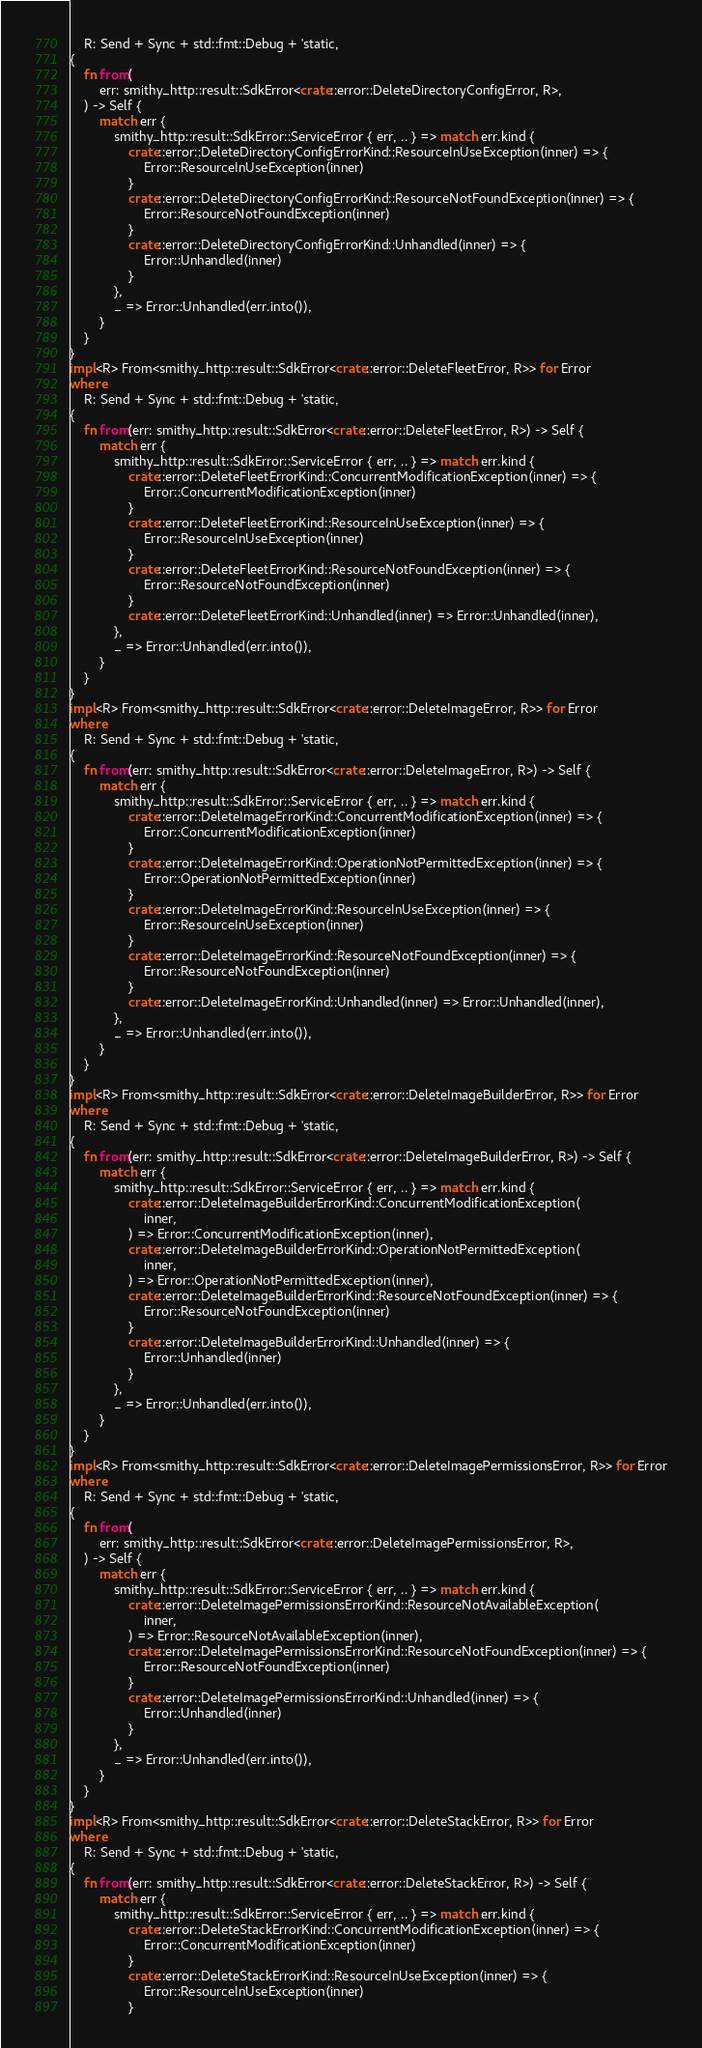Convert code to text. <code><loc_0><loc_0><loc_500><loc_500><_Rust_>    R: Send + Sync + std::fmt::Debug + 'static,
{
    fn from(
        err: smithy_http::result::SdkError<crate::error::DeleteDirectoryConfigError, R>,
    ) -> Self {
        match err {
            smithy_http::result::SdkError::ServiceError { err, .. } => match err.kind {
                crate::error::DeleteDirectoryConfigErrorKind::ResourceInUseException(inner) => {
                    Error::ResourceInUseException(inner)
                }
                crate::error::DeleteDirectoryConfigErrorKind::ResourceNotFoundException(inner) => {
                    Error::ResourceNotFoundException(inner)
                }
                crate::error::DeleteDirectoryConfigErrorKind::Unhandled(inner) => {
                    Error::Unhandled(inner)
                }
            },
            _ => Error::Unhandled(err.into()),
        }
    }
}
impl<R> From<smithy_http::result::SdkError<crate::error::DeleteFleetError, R>> for Error
where
    R: Send + Sync + std::fmt::Debug + 'static,
{
    fn from(err: smithy_http::result::SdkError<crate::error::DeleteFleetError, R>) -> Self {
        match err {
            smithy_http::result::SdkError::ServiceError { err, .. } => match err.kind {
                crate::error::DeleteFleetErrorKind::ConcurrentModificationException(inner) => {
                    Error::ConcurrentModificationException(inner)
                }
                crate::error::DeleteFleetErrorKind::ResourceInUseException(inner) => {
                    Error::ResourceInUseException(inner)
                }
                crate::error::DeleteFleetErrorKind::ResourceNotFoundException(inner) => {
                    Error::ResourceNotFoundException(inner)
                }
                crate::error::DeleteFleetErrorKind::Unhandled(inner) => Error::Unhandled(inner),
            },
            _ => Error::Unhandled(err.into()),
        }
    }
}
impl<R> From<smithy_http::result::SdkError<crate::error::DeleteImageError, R>> for Error
where
    R: Send + Sync + std::fmt::Debug + 'static,
{
    fn from(err: smithy_http::result::SdkError<crate::error::DeleteImageError, R>) -> Self {
        match err {
            smithy_http::result::SdkError::ServiceError { err, .. } => match err.kind {
                crate::error::DeleteImageErrorKind::ConcurrentModificationException(inner) => {
                    Error::ConcurrentModificationException(inner)
                }
                crate::error::DeleteImageErrorKind::OperationNotPermittedException(inner) => {
                    Error::OperationNotPermittedException(inner)
                }
                crate::error::DeleteImageErrorKind::ResourceInUseException(inner) => {
                    Error::ResourceInUseException(inner)
                }
                crate::error::DeleteImageErrorKind::ResourceNotFoundException(inner) => {
                    Error::ResourceNotFoundException(inner)
                }
                crate::error::DeleteImageErrorKind::Unhandled(inner) => Error::Unhandled(inner),
            },
            _ => Error::Unhandled(err.into()),
        }
    }
}
impl<R> From<smithy_http::result::SdkError<crate::error::DeleteImageBuilderError, R>> for Error
where
    R: Send + Sync + std::fmt::Debug + 'static,
{
    fn from(err: smithy_http::result::SdkError<crate::error::DeleteImageBuilderError, R>) -> Self {
        match err {
            smithy_http::result::SdkError::ServiceError { err, .. } => match err.kind {
                crate::error::DeleteImageBuilderErrorKind::ConcurrentModificationException(
                    inner,
                ) => Error::ConcurrentModificationException(inner),
                crate::error::DeleteImageBuilderErrorKind::OperationNotPermittedException(
                    inner,
                ) => Error::OperationNotPermittedException(inner),
                crate::error::DeleteImageBuilderErrorKind::ResourceNotFoundException(inner) => {
                    Error::ResourceNotFoundException(inner)
                }
                crate::error::DeleteImageBuilderErrorKind::Unhandled(inner) => {
                    Error::Unhandled(inner)
                }
            },
            _ => Error::Unhandled(err.into()),
        }
    }
}
impl<R> From<smithy_http::result::SdkError<crate::error::DeleteImagePermissionsError, R>> for Error
where
    R: Send + Sync + std::fmt::Debug + 'static,
{
    fn from(
        err: smithy_http::result::SdkError<crate::error::DeleteImagePermissionsError, R>,
    ) -> Self {
        match err {
            smithy_http::result::SdkError::ServiceError { err, .. } => match err.kind {
                crate::error::DeleteImagePermissionsErrorKind::ResourceNotAvailableException(
                    inner,
                ) => Error::ResourceNotAvailableException(inner),
                crate::error::DeleteImagePermissionsErrorKind::ResourceNotFoundException(inner) => {
                    Error::ResourceNotFoundException(inner)
                }
                crate::error::DeleteImagePermissionsErrorKind::Unhandled(inner) => {
                    Error::Unhandled(inner)
                }
            },
            _ => Error::Unhandled(err.into()),
        }
    }
}
impl<R> From<smithy_http::result::SdkError<crate::error::DeleteStackError, R>> for Error
where
    R: Send + Sync + std::fmt::Debug + 'static,
{
    fn from(err: smithy_http::result::SdkError<crate::error::DeleteStackError, R>) -> Self {
        match err {
            smithy_http::result::SdkError::ServiceError { err, .. } => match err.kind {
                crate::error::DeleteStackErrorKind::ConcurrentModificationException(inner) => {
                    Error::ConcurrentModificationException(inner)
                }
                crate::error::DeleteStackErrorKind::ResourceInUseException(inner) => {
                    Error::ResourceInUseException(inner)
                }</code> 